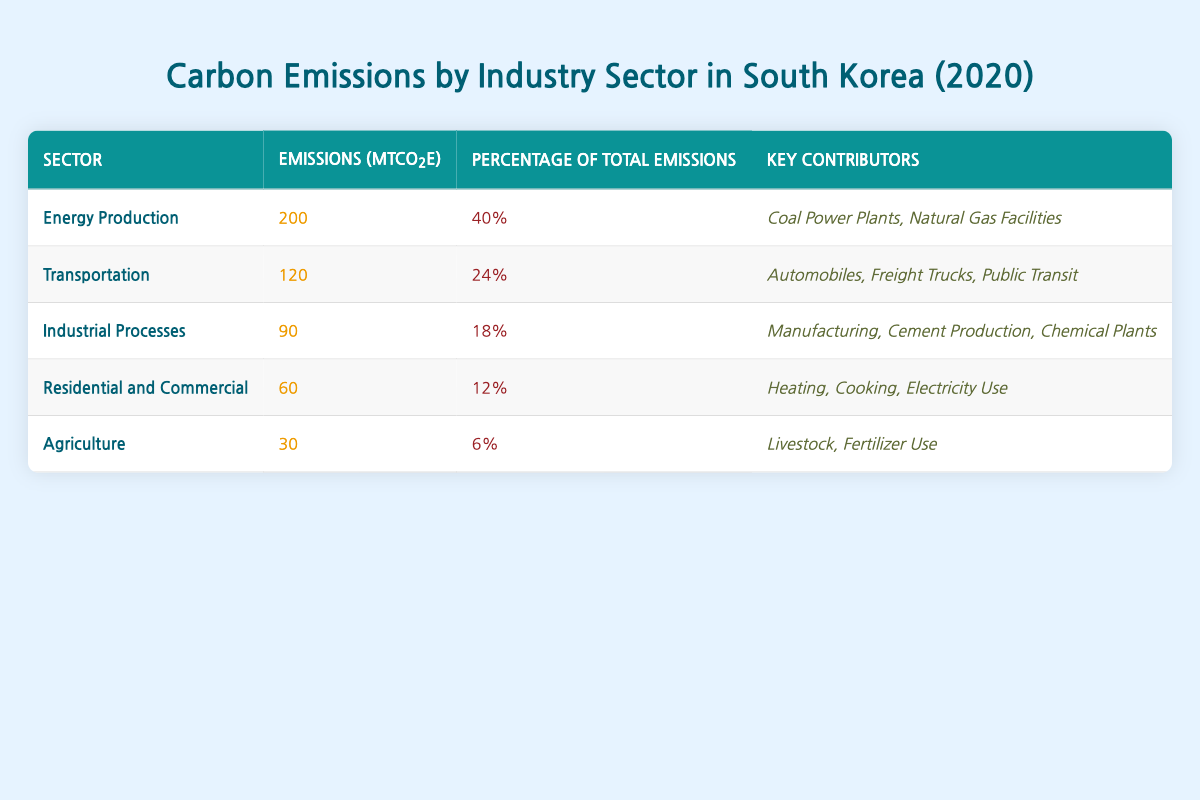What is the total carbon emissions from all sectors in South Korea for 2020? To find the total emissions, we sum the emissions from all sectors: 200 + 120 + 90 + 60 + 30 = 500 MtCO2e.
Answer: 500 MtCO2e Which sector has the highest carbon emissions? By reviewing the table, the sector with the highest emissions is Energy Production, which has 200 MtCO2e.
Answer: Energy Production What percentage of total emissions comes from Agriculture? The percentage of total emissions from Agriculture is directly stated in the table as 6%.
Answer: 6% How many times higher are the emissions from Energy Production compared to Agriculture? The emissions for Energy Production are 200 MtCO2e and for Agriculture, they are 30 MtCO2e. Dividing these gives 200 / 30 = 6.67. Therefore, Energy Production's emissions are approximately 6.67 times higher than Agriculture's.
Answer: Approximately 6.67 times Is the carbon emission from the Industrial Processes sector greater than the emissions from Residential and Commercial sectors combined? The emissions from Industrial Processes are 90 MtCO2e, while Residential and Commercial combined are 60 MtCO2e. Adding these gives 60 + 60 = 120 MtCO2e, which is greater than 90 MtCO2e. Therefore, the statement is true.
Answer: Yes What is the average percentage of emissions across all sectors? To calculate the average percentage, we first sum the percentages: 40 + 24 + 18 + 12 + 6 = 100%. There are 5 sectors, so we divide by 5: 100% / 5 = 20%.
Answer: 20% Which sector contributes the least to carbon emissions and what are its key contributors? The sector with the least emissions is Agriculture with 30 MtCO2e. Its key contributors are Livestock and Fertilizer Use, which are mentioned in the table.
Answer: Agriculture; Livestock, Fertilizer Use How much does the Transportation sector contribute to total emissions compared to the Energy Production sector? Transportation contributes 120 MtCO2e while Energy Production contributes 200 MtCO2e. To find the percentage contribution of Transportation compared to Energy Production, we use the formula: (120 / 200) * 100 = 60%. Thus, Transportation contributes 60% of Energy Production's emissions.
Answer: 60% What is the difference in emissions between the Energy Production sector and the Industrial Processes sector? The emissions for Energy Production are 200 MtCO2e, and for Industrial Processes, they are 90 MtCO2e. The difference is calculated as 200 - 90 = 110 MtCO2e.
Answer: 110 MtCO2e What portion of total emissions in South Korea for 2020 was accounted for by the Residential and Commercial sector? The emissions from Residential and Commercial are 60 MtCO2e, and the total emissions are 500 MtCO2e. To find the portion, we divide: (60 / 500) * 100 = 12%.
Answer: 12% 